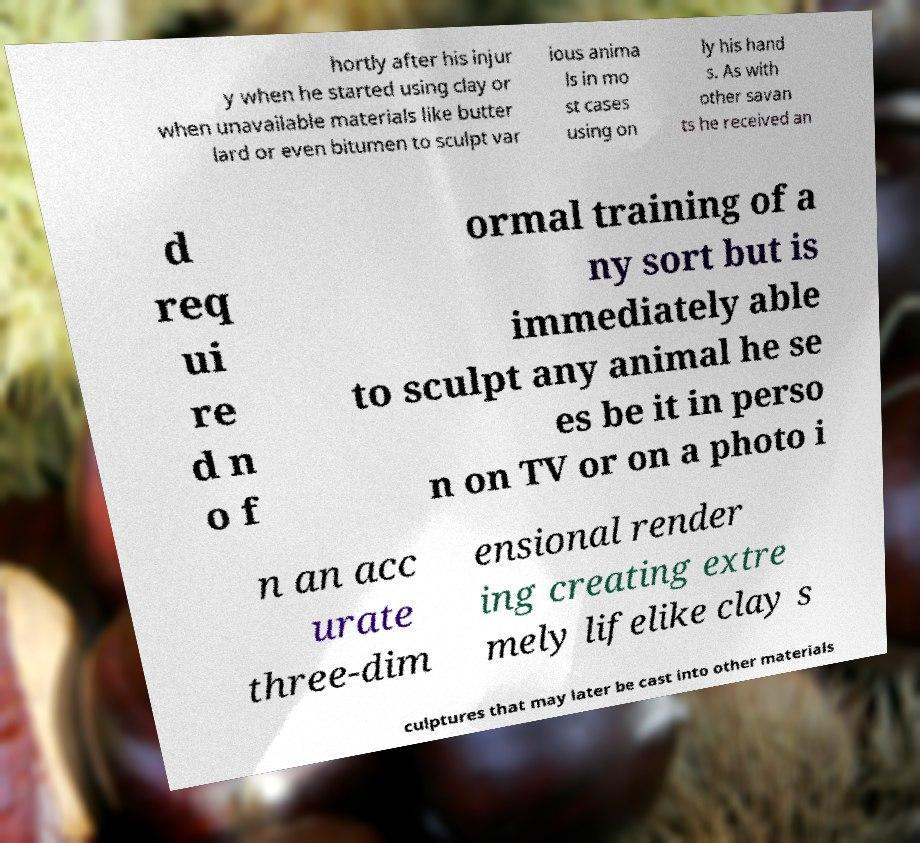Please read and relay the text visible in this image. What does it say? hortly after his injur y when he started using clay or when unavailable materials like butter lard or even bitumen to sculpt var ious anima ls in mo st cases using on ly his hand s. As with other savan ts he received an d req ui re d n o f ormal training of a ny sort but is immediately able to sculpt any animal he se es be it in perso n on TV or on a photo i n an acc urate three-dim ensional render ing creating extre mely lifelike clay s culptures that may later be cast into other materials 